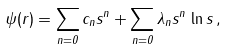<formula> <loc_0><loc_0><loc_500><loc_500>\psi ( r ) = \sum _ { n = 0 } c _ { n } s ^ { n } + \sum _ { n = 0 } \lambda _ { n } s ^ { n } \, \ln s \, ,</formula> 